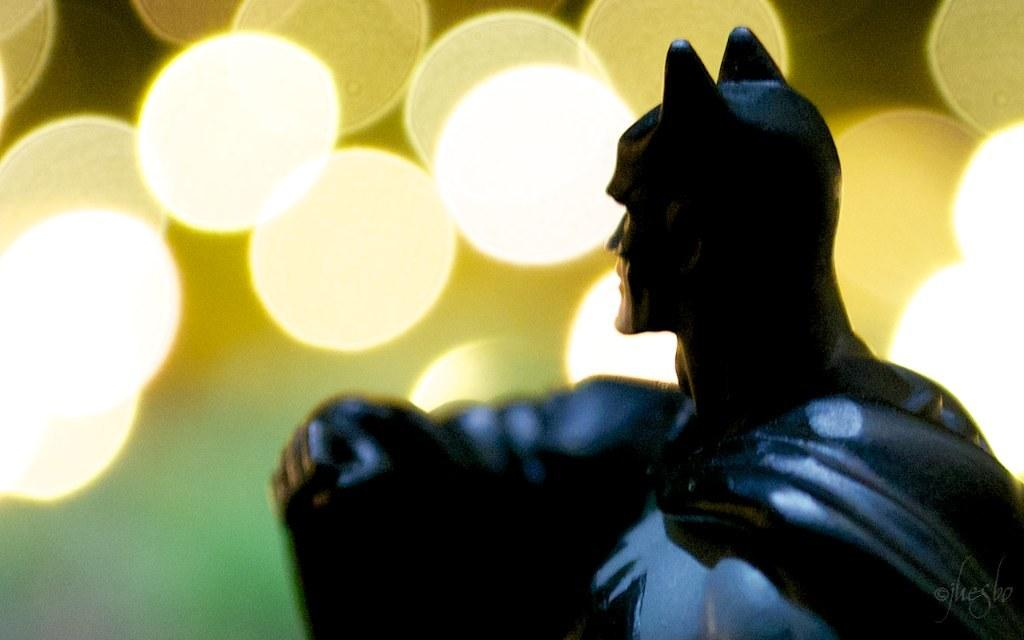What character is the doll in the image designed after? The doll in the image is designed after Batman. What color is the Batman doll? The Batman doll is black in color. What can be seen on the left side of the image? There are lights on the left side of the image. What type of bells can be heard ringing in the image? There are no bells present in the image, so no ringing can be heard. Is the Batman doll on fire in the image? No, the Batman doll is not on fire in the image; it is simply a black doll in the shape of Batman. 